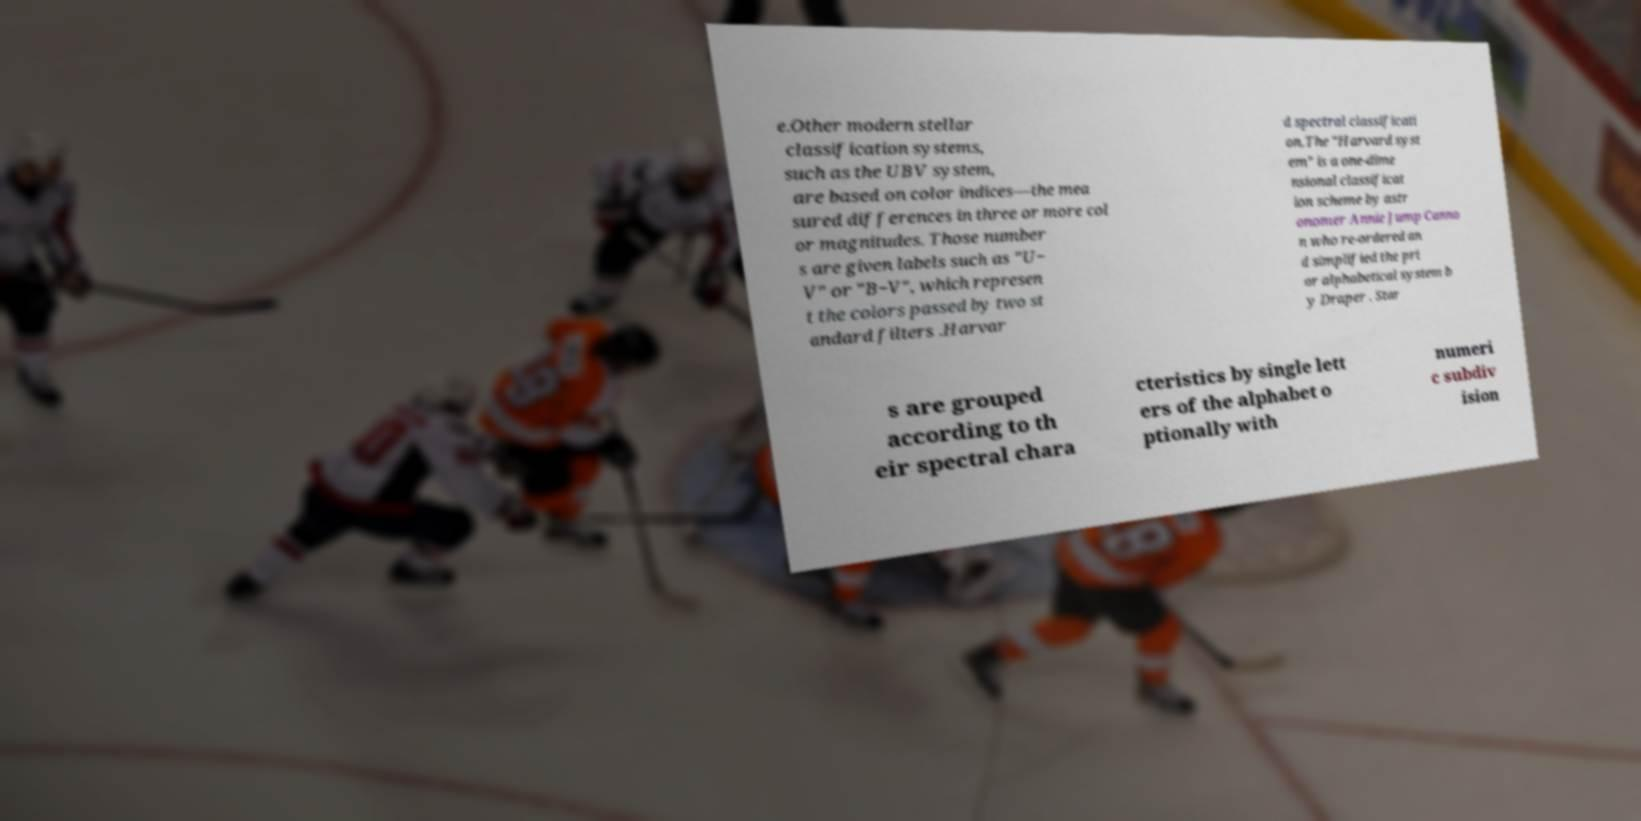Could you assist in decoding the text presented in this image and type it out clearly? e.Other modern stellar classification systems, such as the UBV system, are based on color indices—the mea sured differences in three or more col or magnitudes. Those number s are given labels such as "U− V" or "B−V", which represen t the colors passed by two st andard filters .Harvar d spectral classificati on.The "Harvard syst em" is a one-dime nsional classificat ion scheme by astr onomer Annie Jump Canno n who re-ordered an d simplified the pri or alphabetical system b y Draper . Star s are grouped according to th eir spectral chara cteristics by single lett ers of the alphabet o ptionally with numeri c subdiv ision 